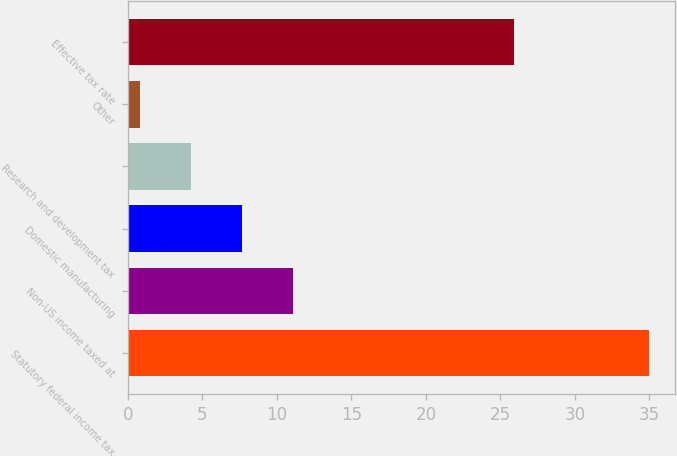Convert chart. <chart><loc_0><loc_0><loc_500><loc_500><bar_chart><fcel>Statutory federal income tax<fcel>Non-US income taxed at<fcel>Domestic manufacturing<fcel>Research and development tax<fcel>Other<fcel>Effective tax rate<nl><fcel>35<fcel>11.06<fcel>7.64<fcel>4.22<fcel>0.8<fcel>25.9<nl></chart> 